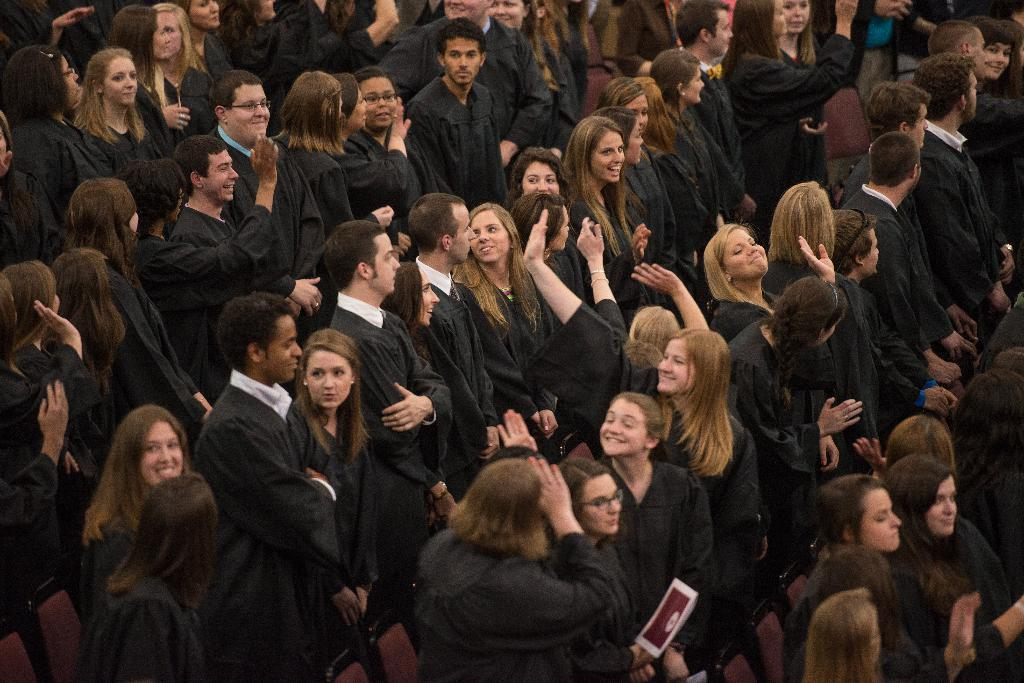How many people are in the image? There are multiple persons in the image. What color clothes are the persons wearing? The persons are wearing black-colored clothes. What are the persons doing in the image? The persons are standing. What type of branch can be seen in the hands of the persons in the image? There is no branch visible in the image; the persons are not holding anything. 